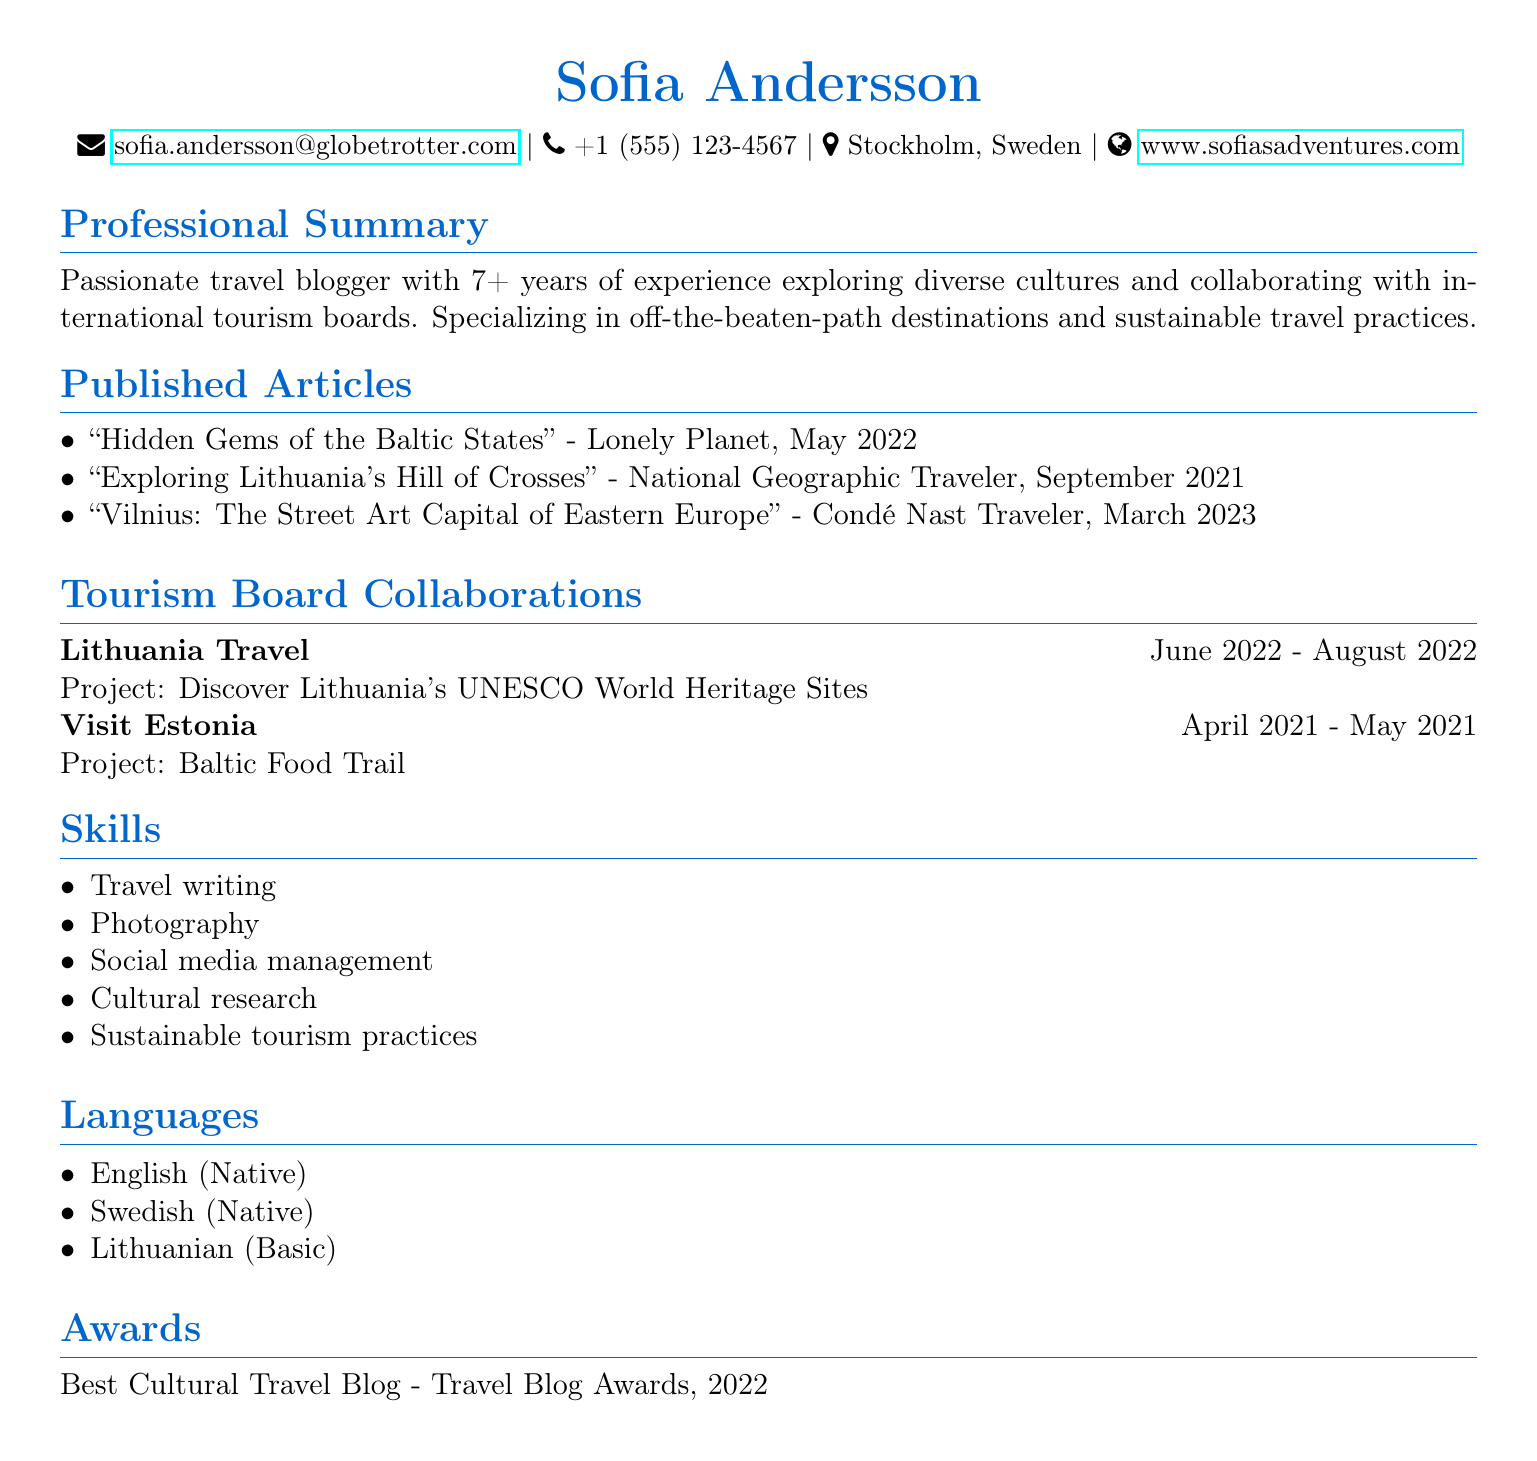What is Sofia Andersson's email address? The email address is listed under personal info in the document.
Answer: sofia.andersson@globetrotter.com When was the article "Exploring Lithuania's Hill of Crosses" published? The article's publication date is provided in the list of published articles.
Answer: September 2021 What organization did Sofia collaborate with for the project on UNESCO World Heritage Sites? The organization is mentioned in the tourism board collaborations section of the document.
Answer: Lithuania Travel How many years of experience does Sofia have as a travel blogger? The years of experience are specified in the professional summary.
Answer: 7+ Which language does Sofia speak at a native level? The languages section indicates her proficiency in specific languages.
Answer: English What award did Sofia receive in 2022? The award is listed in the awards section of the document.
Answer: Best Cultural Travel Blog What was the title of the article published in March 2023? The title is provided in the published articles section of the document.
Answer: Vilnius: The Street Art Capital of Eastern Europe In which city is Sofia located? The location is stated in the personal info section.
Answer: Stockholm, Sweden 